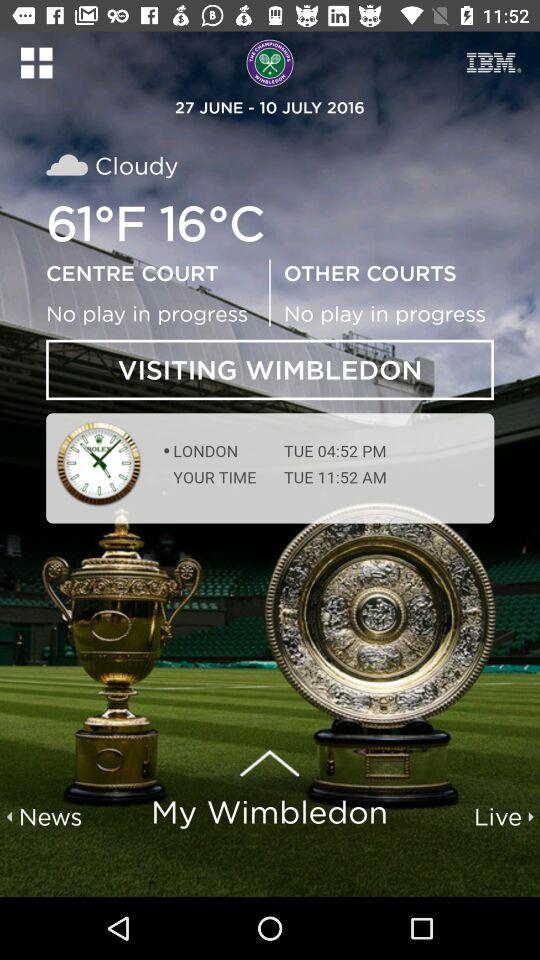How many time zones are displayed on this screen?
Answer the question using a single word or phrase. 2 